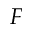<formula> <loc_0><loc_0><loc_500><loc_500>F</formula> 